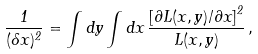Convert formula to latex. <formula><loc_0><loc_0><loc_500><loc_500>\frac { 1 } { ( \delta x ) ^ { 2 } } = \int d y \int d x \, \frac { \left [ \partial L ( x , y ) / \partial x \right ] ^ { 2 } } { L ( x , y ) } \, ,</formula> 